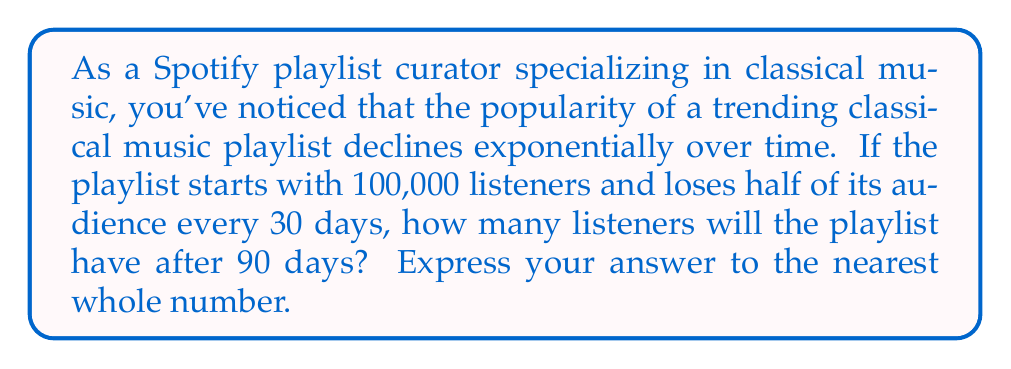Give your solution to this math problem. To solve this problem, we need to use the exponential decay formula and the concept of half-life. Let's break it down step by step:

1) The exponential decay formula is:

   $$ N(t) = N_0 \cdot (0.5)^{t/t_{1/2}} $$

   Where:
   $N(t)$ is the number of listeners at time $t$
   $N_0$ is the initial number of listeners
   $t$ is the time elapsed
   $t_{1/2}$ is the half-life

2) We're given:
   $N_0 = 100,000$ listeners
   $t_{1/2} = 30$ days
   $t = 90$ days

3) Let's substitute these values into our formula:

   $$ N(90) = 100,000 \cdot (0.5)^{90/30} $$

4) Simplify the exponent:

   $$ N(90) = 100,000 \cdot (0.5)^3 $$

5) Calculate $(0.5)^3$:
   
   $$ (0.5)^3 = 0.5 \cdot 0.5 \cdot 0.5 = 0.125 $$

6) Now our equation looks like:

   $$ N(90) = 100,000 \cdot 0.125 $$

7) Multiply:

   $$ N(90) = 12,500 $$

Therefore, after 90 days, the playlist will have 12,500 listeners.
Answer: 12,500 listeners 